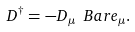Convert formula to latex. <formula><loc_0><loc_0><loc_500><loc_500>D ^ { \dagger } = - D _ { \mu } \ B a r e _ { \mu } .</formula> 